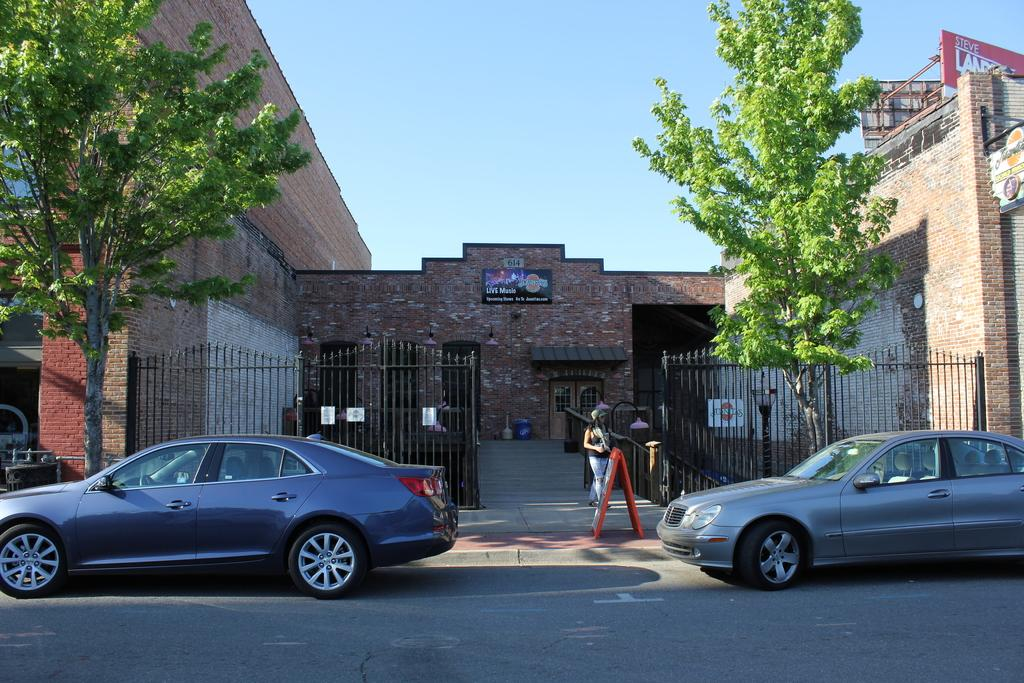What can be seen on the road in the image? There are cars on the road in the image. What type of barrier is present in the image? There is a fence in the image. Can you describe the person in the image? There is a person in the image. What type of vegetation is visible in the image? There are trees in the image. What type of signage can be seen in the image? There are name boards in the image. What type of structures are visible in the image? There are buildings in the image. What type of advertisement is present in the image? There are hoardings in the image. What else can be seen in the image? There are some objects in the image. What is visible in the background of the image? The sky is visible in the background of the image. What type of news is being reported by the carpenter in the image? There is no carpenter or news reporting present in the image. What type of destruction is visible in the image? There is no destruction visible in the image. 